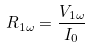Convert formula to latex. <formula><loc_0><loc_0><loc_500><loc_500>R _ { 1 \omega } = \frac { V _ { 1 \omega } } { I _ { 0 } }</formula> 